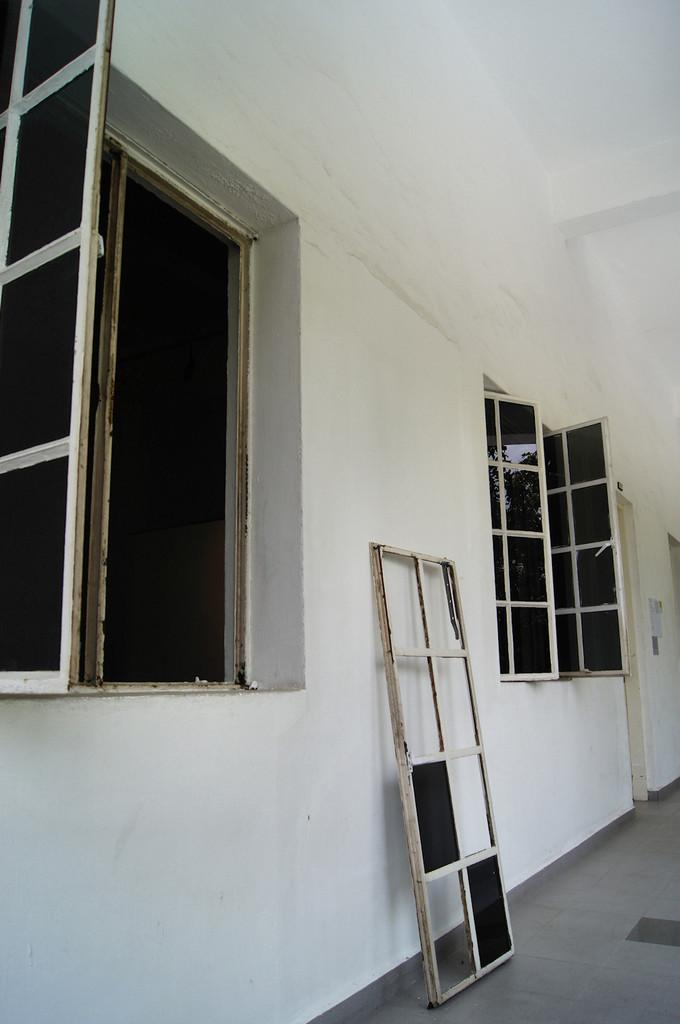What is the main feature of the image? There is a wall in the image. What is unique about the wall? The wall has many windows. What material is used for the windows? The windows have glass panes. What invention can be seen in the image? There is no specific invention visible in the image; it primarily features a wall with many windows. 